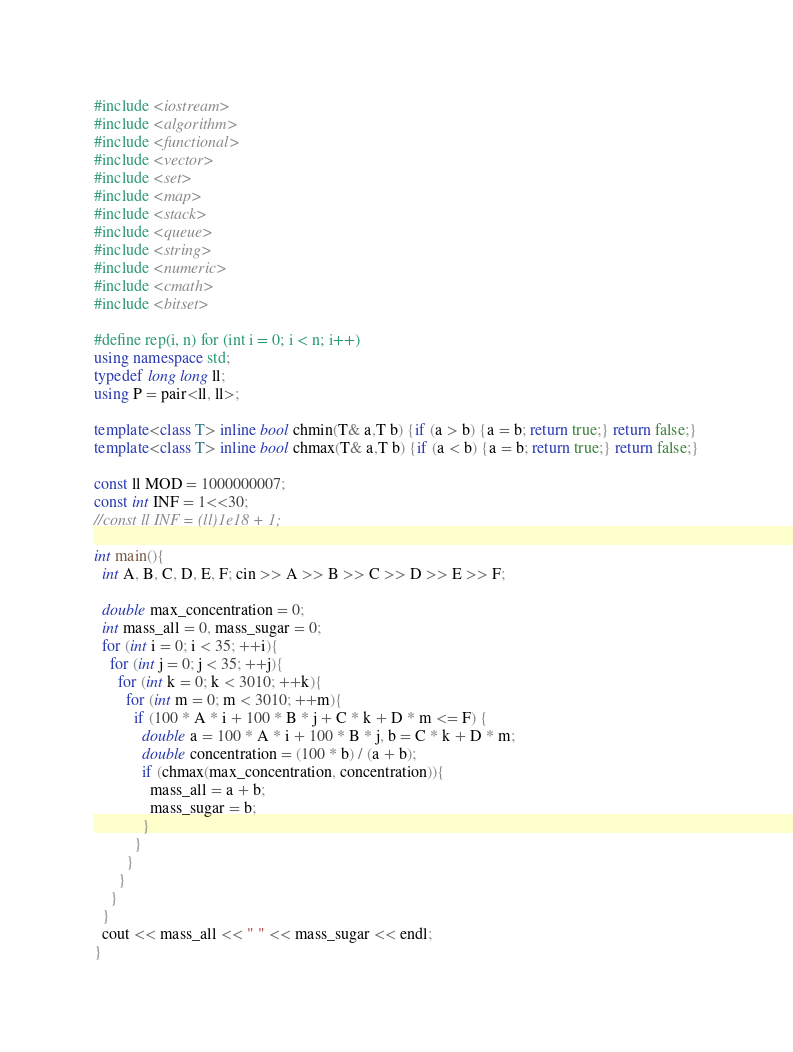<code> <loc_0><loc_0><loc_500><loc_500><_C++_>#include <iostream>
#include <algorithm>
#include <functional>
#include <vector>
#include <set>
#include <map>
#include <stack>
#include <queue>
#include <string>
#include <numeric>
#include <cmath>
#include <bitset>

#define rep(i, n) for (int i = 0; i < n; i++)
using namespace std;
typedef long long ll;
using P = pair<ll, ll>;

template<class T> inline bool chmin(T& a,T b) {if (a > b) {a = b; return true;} return false;}
template<class T> inline bool chmax(T& a,T b) {if (a < b) {a = b; return true;} return false;}

const ll MOD = 1000000007;
const int INF = 1<<30;
//const ll INF = (ll)1e18 + 1;

int main(){
  int A, B, C, D, E, F; cin >> A >> B >> C >> D >> E >> F;

  double max_concentration = 0;
  int mass_all = 0, mass_sugar = 0;
  for (int i = 0; i < 35; ++i){
    for (int j = 0; j < 35; ++j){
      for (int k = 0; k < 3010; ++k){
        for (int m = 0; m < 3010; ++m){
          if (100 * A * i + 100 * B * j + C * k + D * m <= F) {
            double a = 100 * A * i + 100 * B * j, b = C * k + D * m;
            double concentration = (100 * b) / (a + b);
            if (chmax(max_concentration, concentration)){
              mass_all = a + b;
              mass_sugar = b;
            }
          }
        }
      }
    }
  }
  cout << mass_all << " " << mass_sugar << endl;
}
</code> 